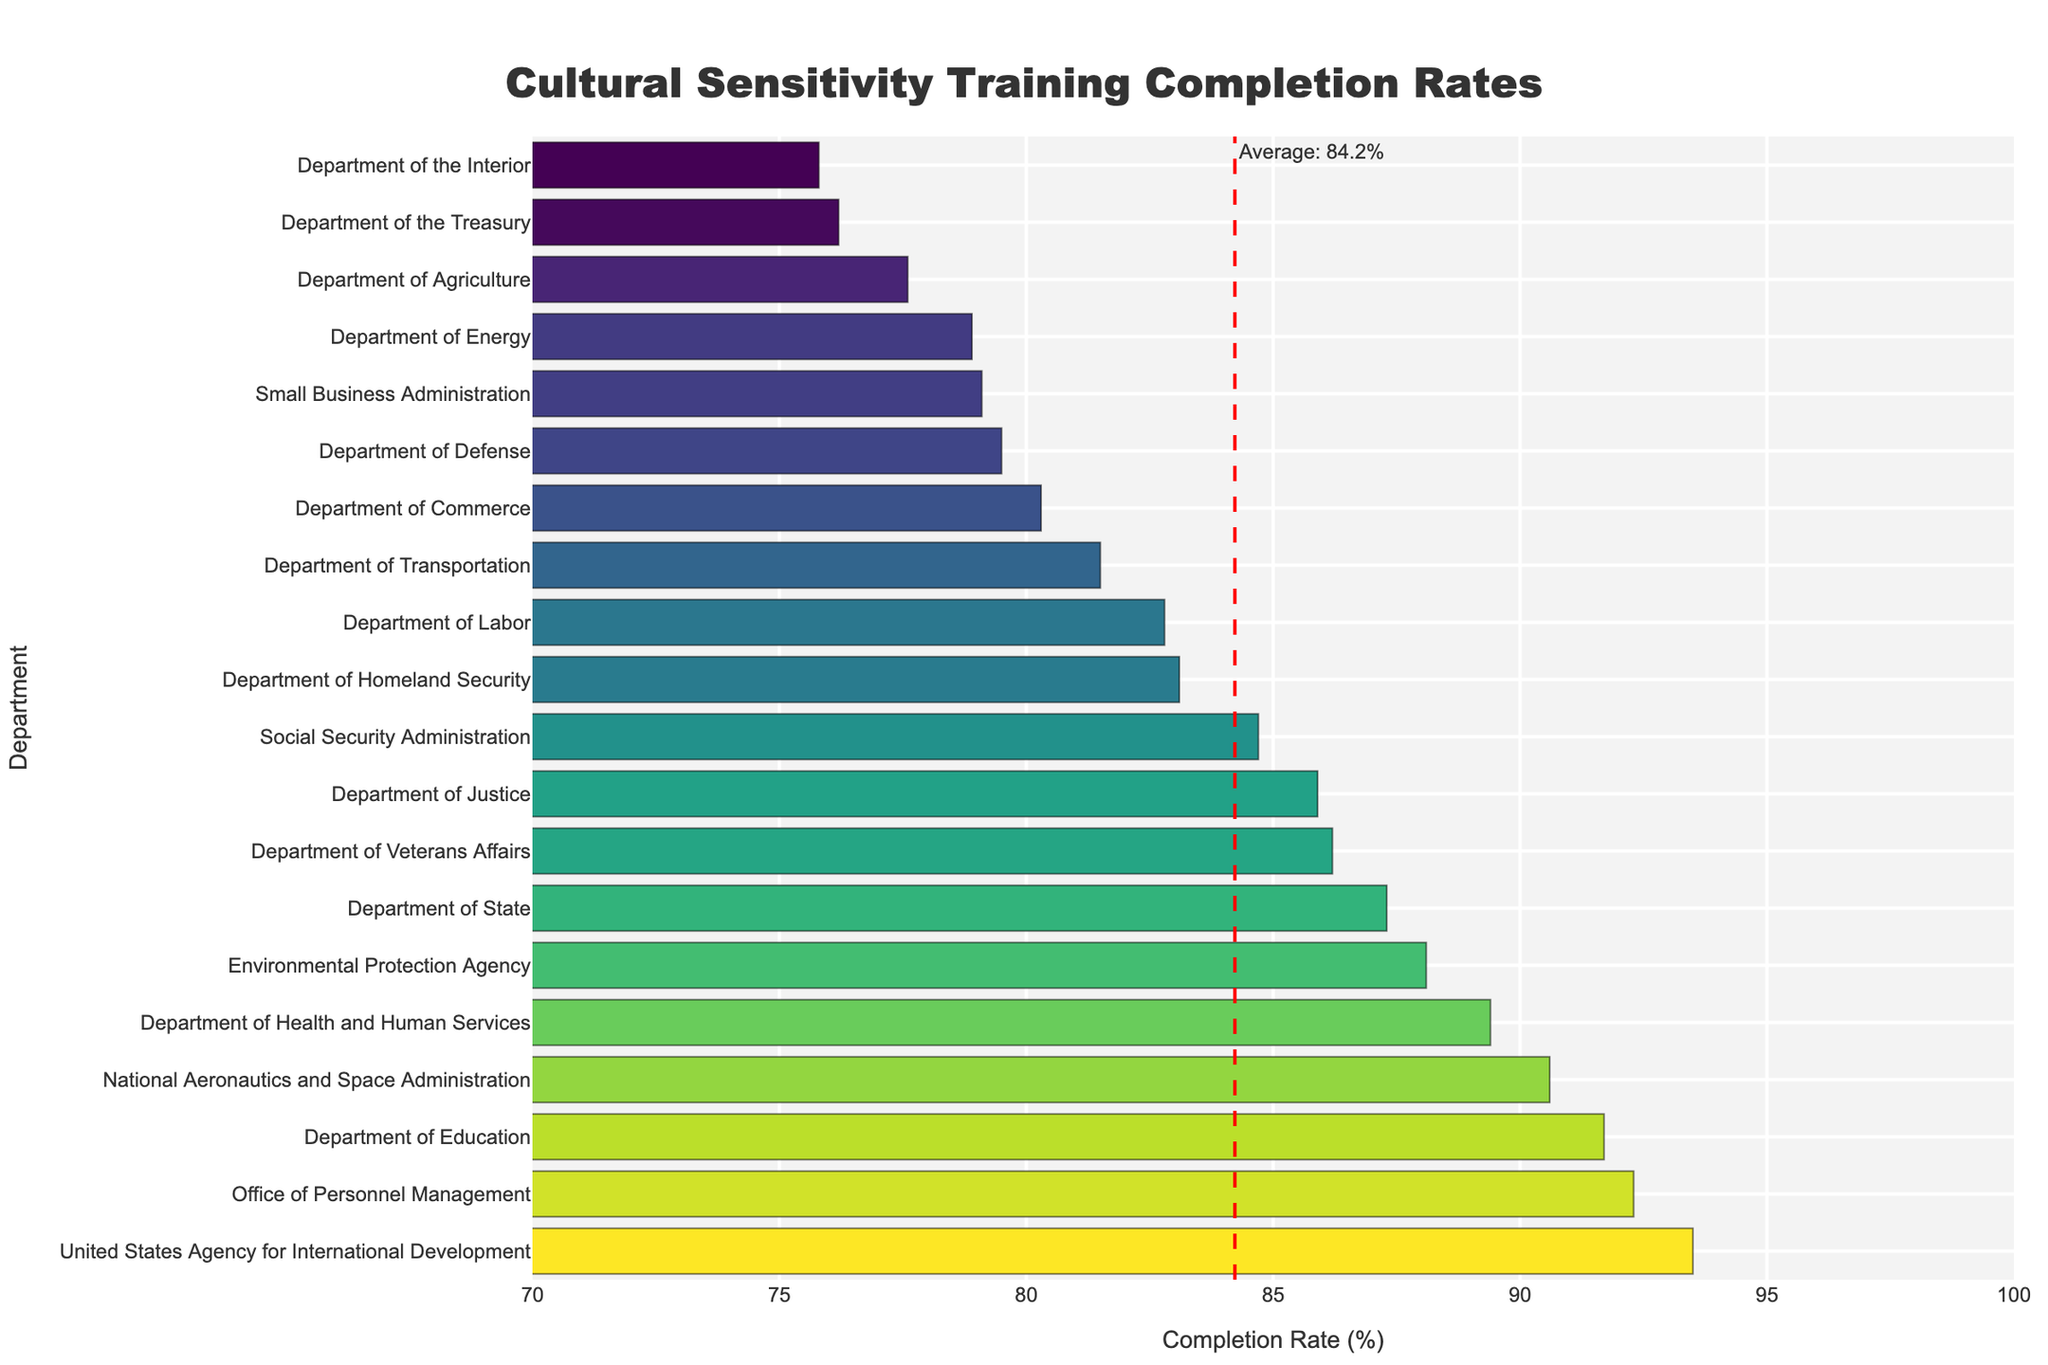What is the highest completion rate? The highest completion rate is 93.5%, as shown by the bar corresponding to the United States Agency for International Development.
Answer: 93.5% Which department has the lowest completion rate? The lowest completion rate, 75.8%, is associated with the Department of the Interior, as indicated by the shortest bar in the chart.
Answer: Department of the Interior How many departments have a completion rate above 90%? By examining the bars that extend beyond the 90% mark on the x-axis, we find 5 departments: Department of Education, National Aeronautics and Space Administration, Office of Personnel Management, and United States Agency for International Development.
Answer: 4 What is the average completion rate of all departments? The red dashed vertical line represents the average completion rate, which is annotated as "Average: 84.2%."
Answer: 84.2% Which departments have completion rates below the average? Departments with bars ending before the red average line (84.2%) are Department of Defense, Department of the Treasury, Department of Agriculture, Department of Energy, Department of Transportation, and Small Business Administration.
Answer: 6 departments How does the completion rate of the Department of Justice compare to the Department of Commerce? The bar for the Department of Justice (85.9%) is longer than that of the Department of Commerce (80.3%), indicating a higher completion rate.
Answer: Department of Justice has a higher completion rate What is the median completion rate? To find the median, list all completion rates in ascending order and find the middle value: 75.8, 76.2, 77.6, 78.9, 79.1, 79.5, 80.3, 81.5, 82.8, 83.1, 84.7, 85.9, 86.2, 87.3, 88.1, 89.4, 90.6, 91.7, 92.3, 93.5. With 20 values, the median is (84.7 + 85.9) / 2 = 85.3%.
Answer: 85.3% What is the difference in completion rates between the Department of Health and Human Services and the Department of Agriculture? Subtract the completion rate of the Department of Agriculture (77.6%) from that of the Department of Health and Human Services (89.4%): 89.4% - 77.6% = 11.8%.
Answer: 11.8% What visual clues indicate which department has a completion rate close to the average? The Department of Labor, with its bar almost at the red average line, indicates a completion rate very close to the average (82.8%).
Answer: Department of Labor Are there more departments above or below the average completion rate? Count the number of bars above and below the red average line (84.2%). There are 9 bars above and 11 below.
Answer: More departments are below the average 